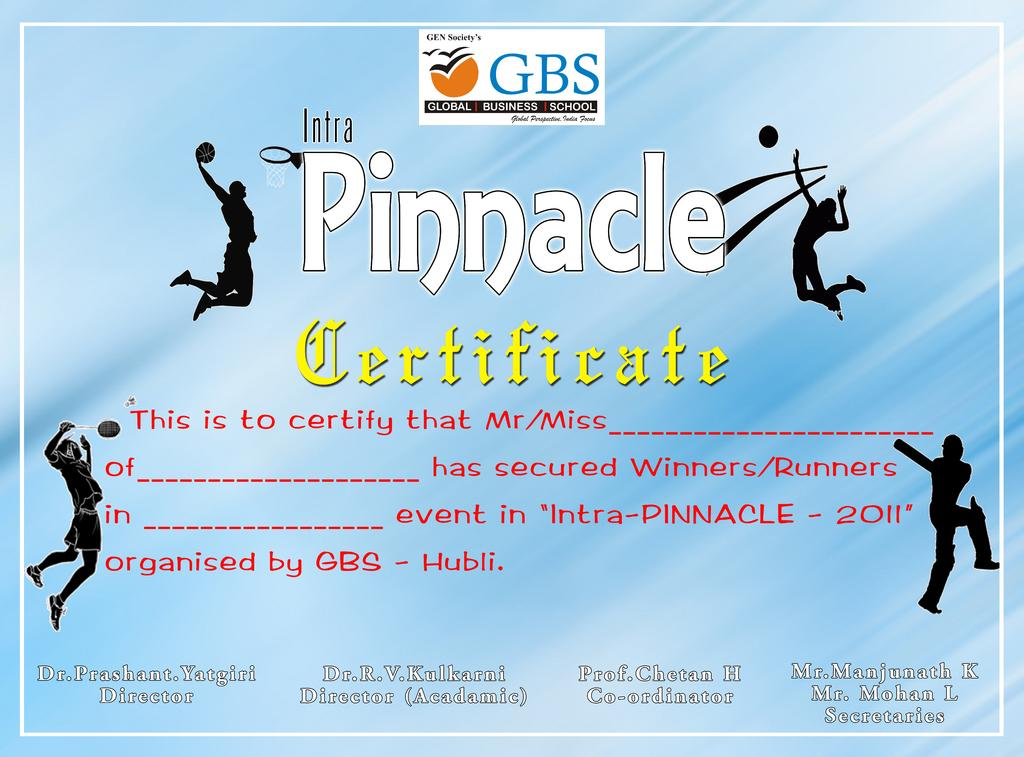<image>
Describe the image concisely. A certificate for a student titled Intra Pinnacle Certificate. 